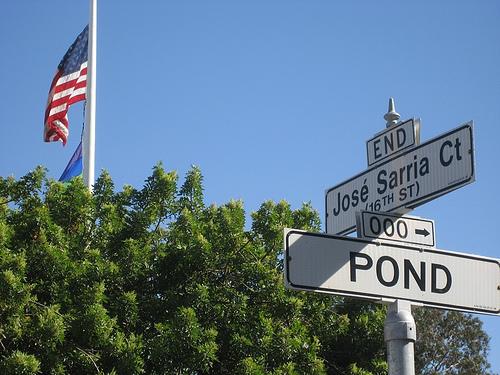How many street signs do you see?
Quick response, please. 2. What street stops at this intersection?
Be succinct. Jose sarria ct. Is it raining?
Be succinct. No. What type of flag is on the top of the flagpole?
Be succinct. American. What object is in the background of the image behind the sign?
Answer briefly. Flag. 